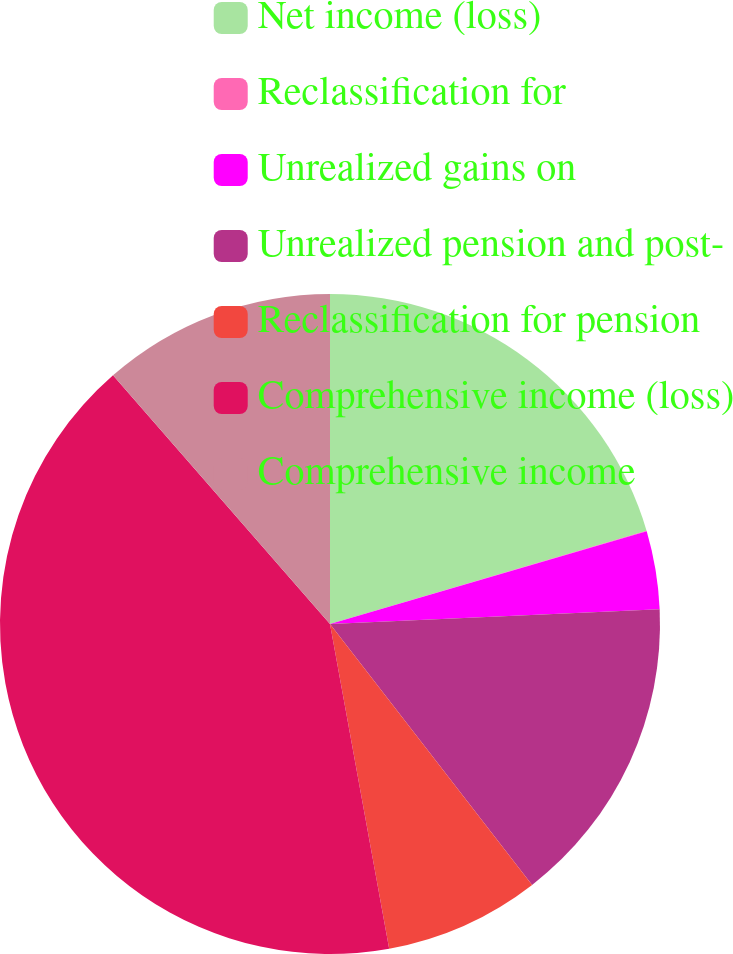<chart> <loc_0><loc_0><loc_500><loc_500><pie_chart><fcel>Net income (loss)<fcel>Reclassification for<fcel>Unrealized gains on<fcel>Unrealized pension and post-<fcel>Reclassification for pension<fcel>Comprehensive income (loss)<fcel>Comprehensive income<nl><fcel>20.44%<fcel>0.03%<fcel>3.82%<fcel>15.22%<fcel>7.62%<fcel>41.45%<fcel>11.42%<nl></chart> 